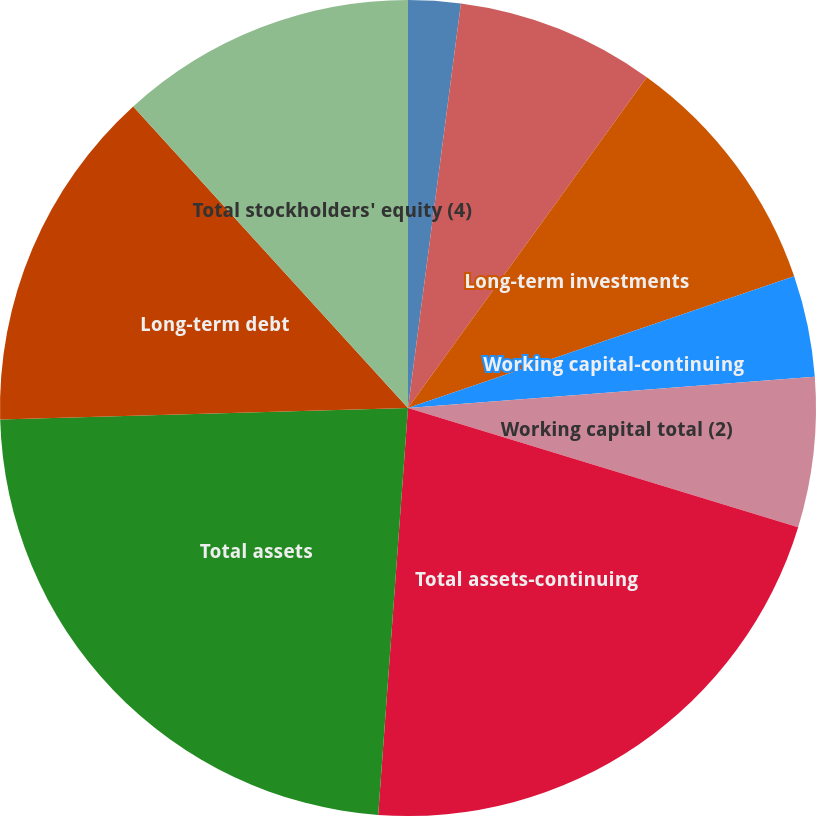Convert chart. <chart><loc_0><loc_0><loc_500><loc_500><pie_chart><fcel>Cash and cash equivalents<fcel>Short-term investments<fcel>Long-term investments<fcel>Working capital-continuing<fcel>Working capital total (2)<fcel>Total assets-continuing<fcel>Total assets<fcel>Long-term debt<fcel>Total stockholders' equity (4)<nl><fcel>2.07%<fcel>7.88%<fcel>9.82%<fcel>4.01%<fcel>5.94%<fcel>21.44%<fcel>23.38%<fcel>13.69%<fcel>11.76%<nl></chart> 